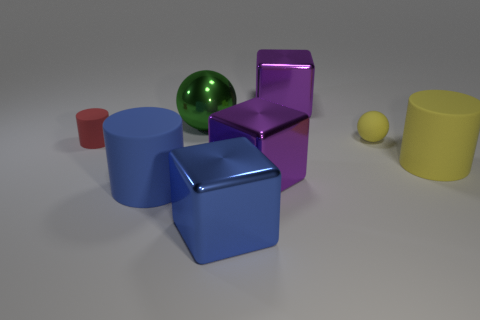What material is the large cylinder to the left of the large metal cube that is in front of the purple thing that is in front of the big yellow matte cylinder?
Give a very brief answer. Rubber. How many things are either matte objects that are left of the big metal ball or small yellow rubber things?
Your answer should be very brief. 3. What number of other things are the same shape as the large blue shiny thing?
Offer a very short reply. 2. Is the number of purple things right of the yellow matte ball greater than the number of red metal balls?
Provide a short and direct response. No. There is a yellow object that is the same shape as the green object; what is its size?
Your response must be concise. Small. Are there any other things that have the same material as the green sphere?
Offer a terse response. Yes. There is a large blue shiny object; what shape is it?
Give a very brief answer. Cube. There is a rubber object that is the same size as the blue cylinder; what shape is it?
Give a very brief answer. Cylinder. Are there any other things of the same color as the big shiny ball?
Your response must be concise. No. What size is the sphere that is the same material as the blue cylinder?
Your answer should be very brief. Small. 